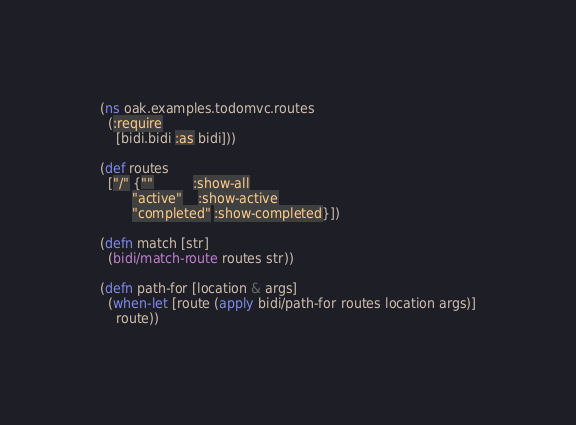Convert code to text. <code><loc_0><loc_0><loc_500><loc_500><_Clojure_>(ns oak.examples.todomvc.routes
  (:require
    [bidi.bidi :as bidi]))

(def routes
  ["/" {""          :show-all
        "active"    :show-active
        "completed" :show-completed}])

(defn match [str]
  (bidi/match-route routes str))

(defn path-for [location & args]
  (when-let [route (apply bidi/path-for routes location args)]
    route))
</code> 